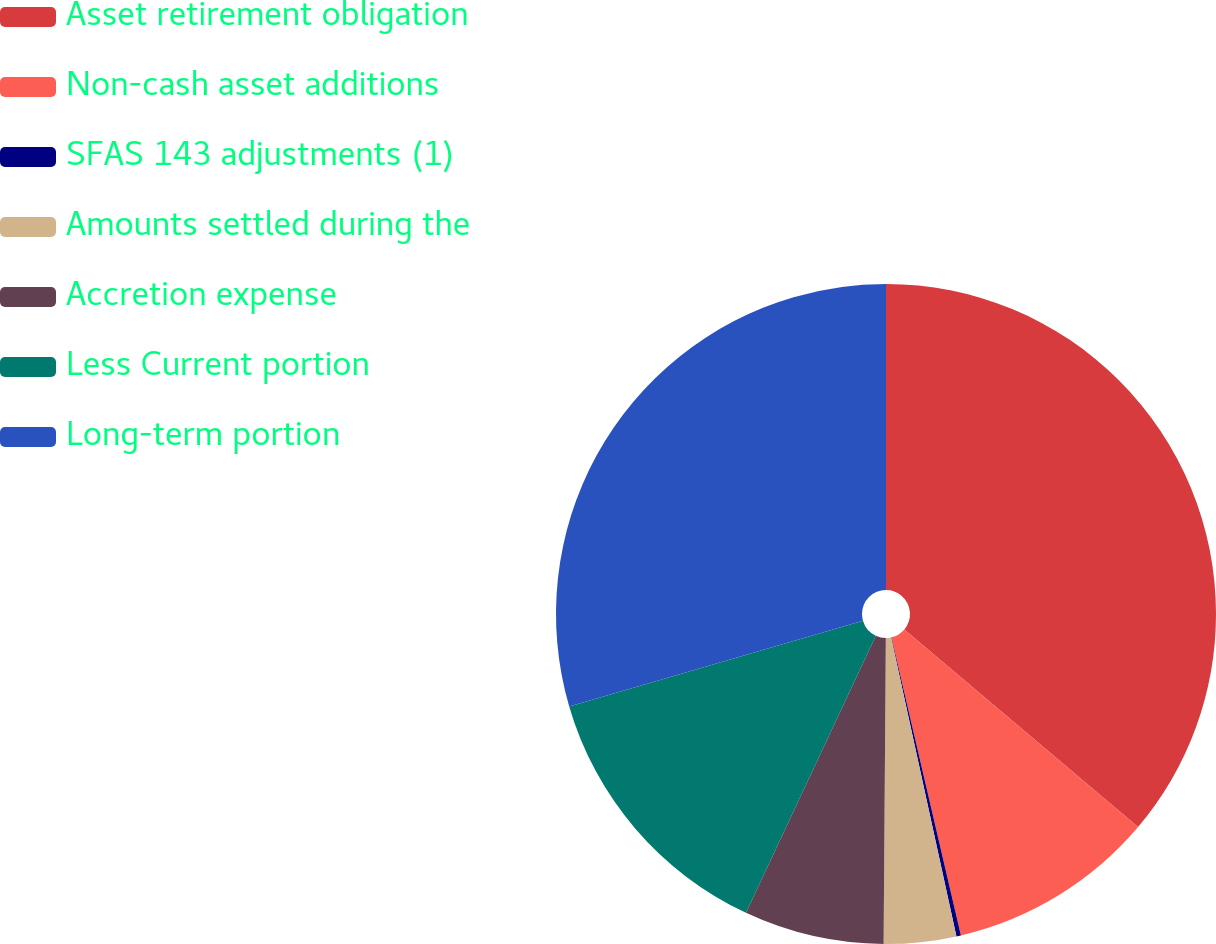Convert chart. <chart><loc_0><loc_0><loc_500><loc_500><pie_chart><fcel>Asset retirement obligation<fcel>Non-cash asset additions<fcel>SFAS 143 adjustments (1)<fcel>Amounts settled during the<fcel>Accretion expense<fcel>Less Current portion<fcel>Long-term portion<nl><fcel>36.17%<fcel>10.19%<fcel>0.22%<fcel>3.54%<fcel>6.86%<fcel>13.51%<fcel>29.52%<nl></chart> 